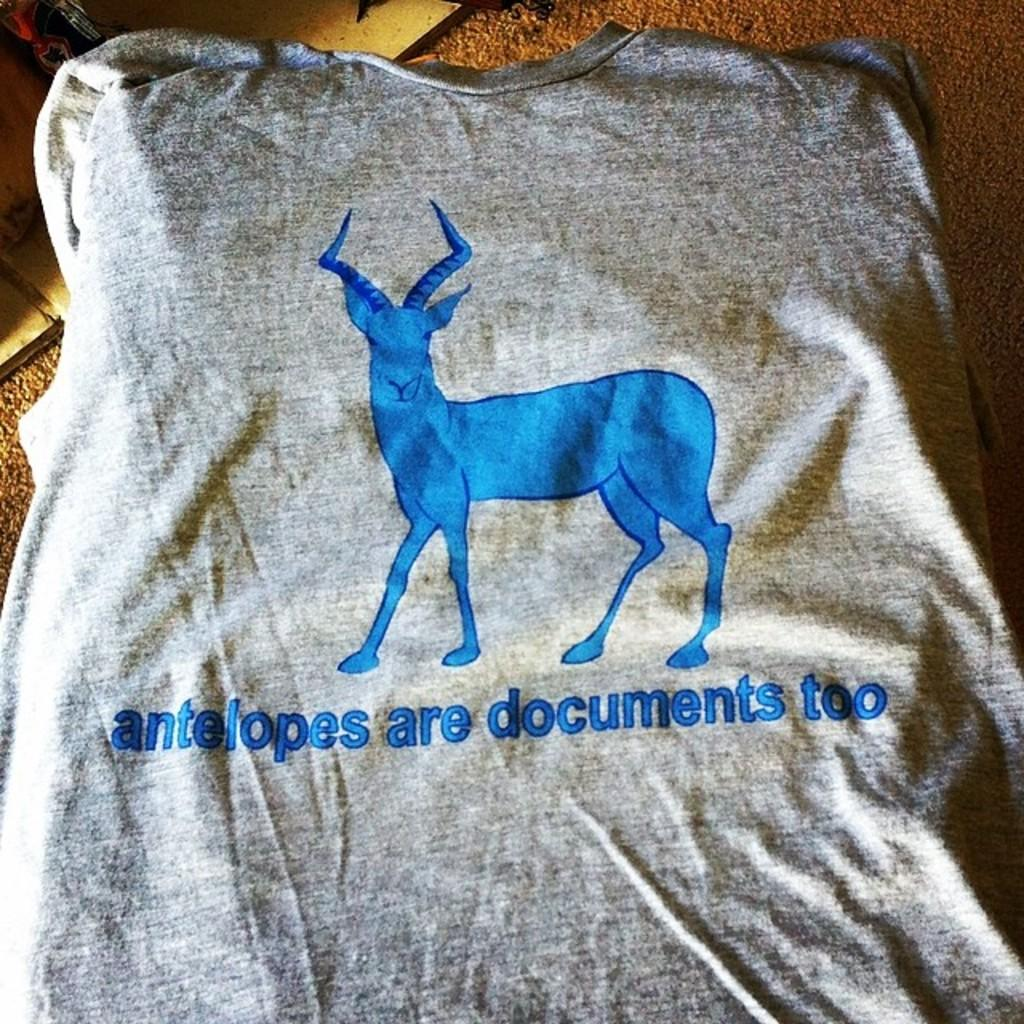What is the main subject of the image? There is an animal depicted on a t-shirt in the image. How many toes does the animal on the t-shirt have? The image does not show the animal's toes, as it is only a depiction on a t-shirt. 